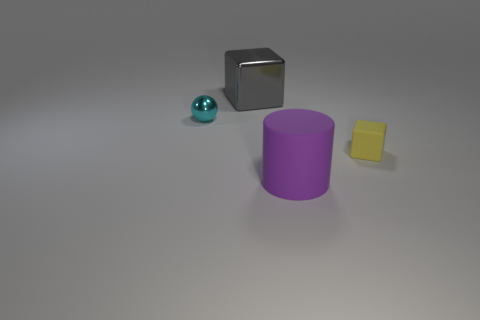Is the number of blocks greater than the number of things?
Make the answer very short. No. The other tiny matte object that is the same shape as the gray object is what color?
Ensure brevity in your answer.  Yellow. There is a object that is both behind the large rubber thing and in front of the cyan ball; what is it made of?
Offer a terse response. Rubber. Is the material of the tiny thing on the right side of the big purple thing the same as the thing that is in front of the tiny matte cube?
Your response must be concise. Yes. How big is the purple cylinder?
Your answer should be very brief. Large. The other thing that is the same shape as the big gray object is what size?
Keep it short and to the point. Small. There is a rubber cube; how many big things are in front of it?
Provide a short and direct response. 1. There is a tiny object right of the block that is behind the tiny cube; what color is it?
Keep it short and to the point. Yellow. Is there any other thing that has the same shape as the purple rubber object?
Your response must be concise. No. Are there the same number of big purple matte things that are left of the big metallic block and gray shiny things that are in front of the big purple matte object?
Offer a terse response. Yes. 